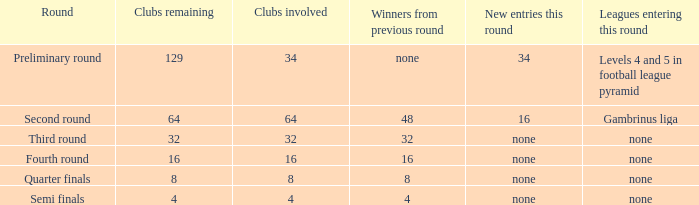Name the least clubs remaining 4.0. 